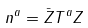Convert formula to latex. <formula><loc_0><loc_0><loc_500><loc_500>n ^ { a } = \bar { Z } T ^ { a } Z</formula> 